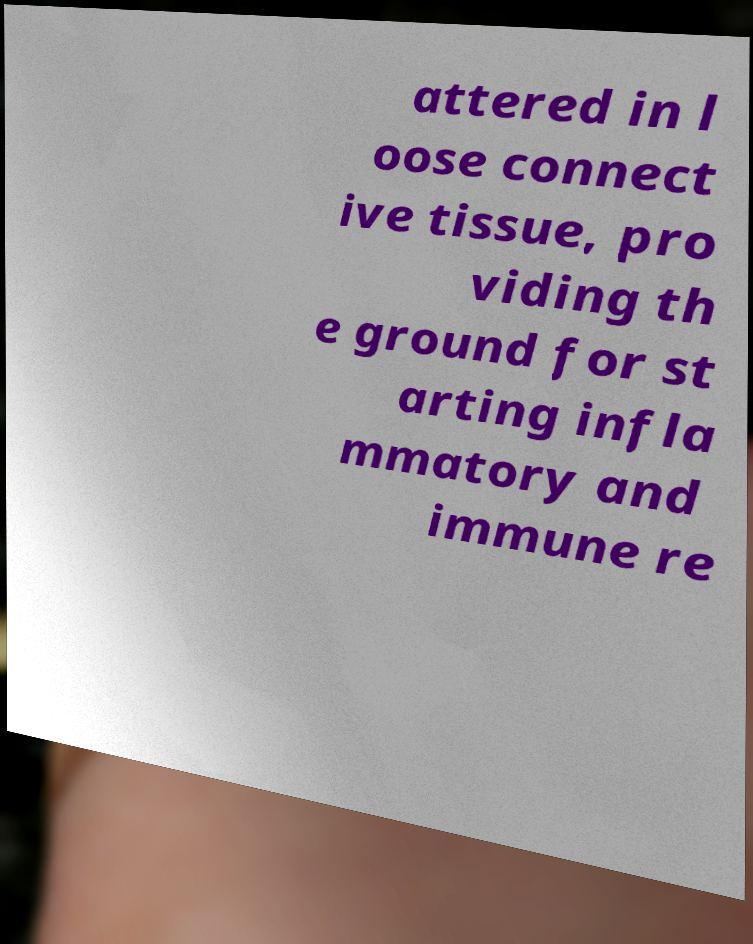Can you accurately transcribe the text from the provided image for me? attered in l oose connect ive tissue, pro viding th e ground for st arting infla mmatory and immune re 